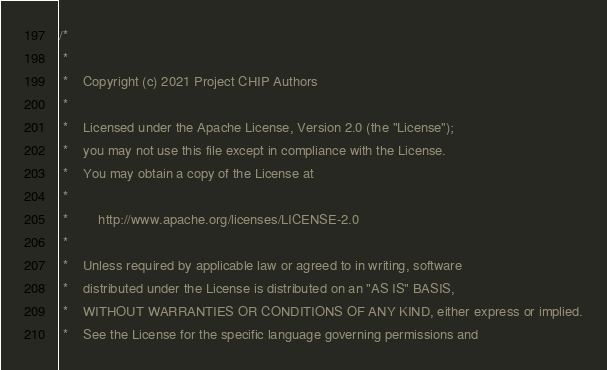<code> <loc_0><loc_0><loc_500><loc_500><_ObjectiveC_>/*
 *
 *    Copyright (c) 2021 Project CHIP Authors
 *
 *    Licensed under the Apache License, Version 2.0 (the "License");
 *    you may not use this file except in compliance with the License.
 *    You may obtain a copy of the License at
 *
 *        http://www.apache.org/licenses/LICENSE-2.0
 *
 *    Unless required by applicable law or agreed to in writing, software
 *    distributed under the License is distributed on an "AS IS" BASIS,
 *    WITHOUT WARRANTIES OR CONDITIONS OF ANY KIND, either express or implied.
 *    See the License for the specific language governing permissions and</code> 